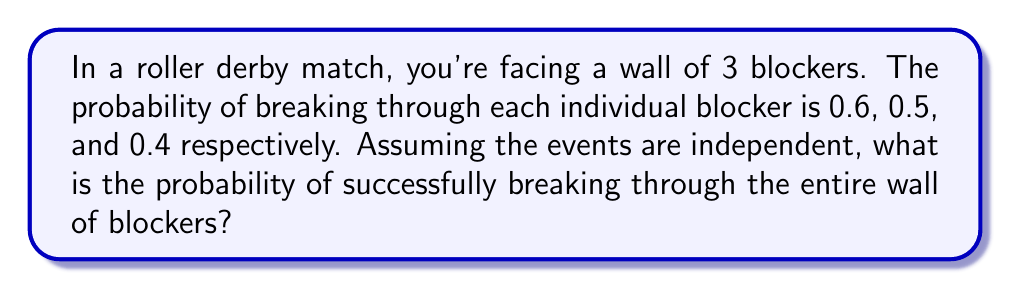Give your solution to this math problem. Let's approach this step-by-step:

1) For independent events, the probability of all events occurring is the product of their individual probabilities.

2) Let's define our events:
   A: Breaking through the first blocker (P(A) = 0.6)
   B: Breaking through the second blocker (P(B) = 0.5)
   C: Breaking through the third blocker (P(C) = 0.4)

3) We want to find P(A and B and C)

4) Given that these events are independent:

   $$P(A \text{ and } B \text{ and } C) = P(A) \times P(B) \times P(C)$$

5) Substituting the given probabilities:

   $$P(A \text{ and } B \text{ and } C) = 0.6 \times 0.5 \times 0.4$$

6) Calculating:

   $$P(A \text{ and } B \text{ and } C) = 0.12$$

7) Therefore, the probability of successfully breaking through the entire wall of blockers is 0.12 or 12%.
Answer: $0.12$ or $12\%$ 